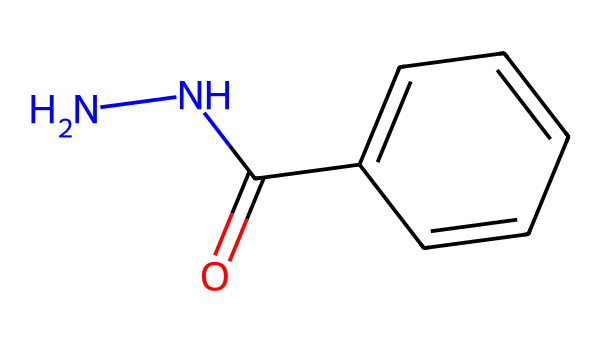What is the molecular formula of the compound represented in the SMILES? The SMILES string indicates the presence of nitrogen (N), carbon (C), and oxygen (O). Counting these atoms gives a molecular formula of C7H8N2O.
Answer: C7H8N2O How many nitrogen atoms are present in the chemical structure? In the SMILES representation, there are two nitrogen atoms indicated by "N".
Answer: 2 What functional group is indicated by "C(=O)" in the structure? The "C(=O)" notation indicates a carbonyl group (specifically a ketone or aldehyde), which includes a carbon atom double-bonded to an oxygen atom.
Answer: carbonyl What is the common use of the hydrazine derivative shown? This hydrazine derivative is often used in anti-corrosion coatings, specifically designed for metal surfaces such as train tracks.
Answer: anti-corrosion How does the presence of the aromatic ring (c1ccccc1) affect the properties of the compound? The aromatic ring contributes stability and may enhance the hydrophobic character of the compound, potentially affecting its adhesion and protective qualities in coatings.
Answer: stability Which part of the chemical structure contributes to its hydrazine characteristic? The "NNC" portion indicates the presence of the hydrazine backbone, which is a defining feature of hydrazines and contributes to their reactivity and bonding.
Answer: NNC 